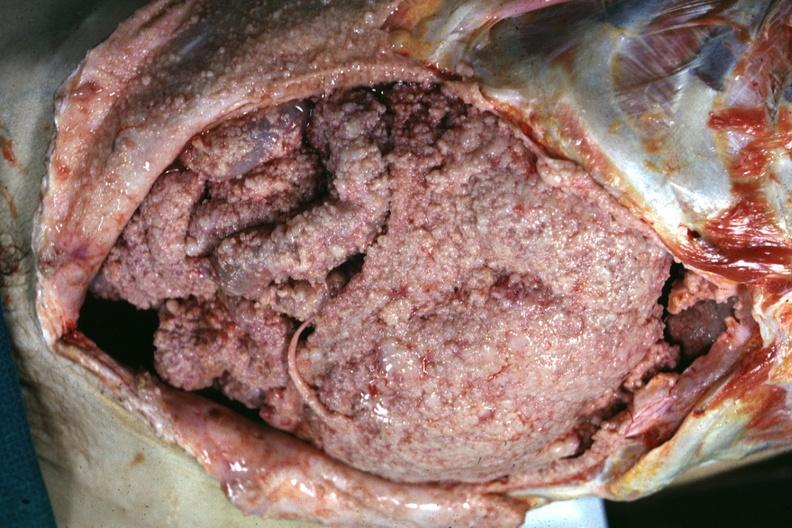what is present?
Answer the question using a single word or phrase. Mesothelioma 